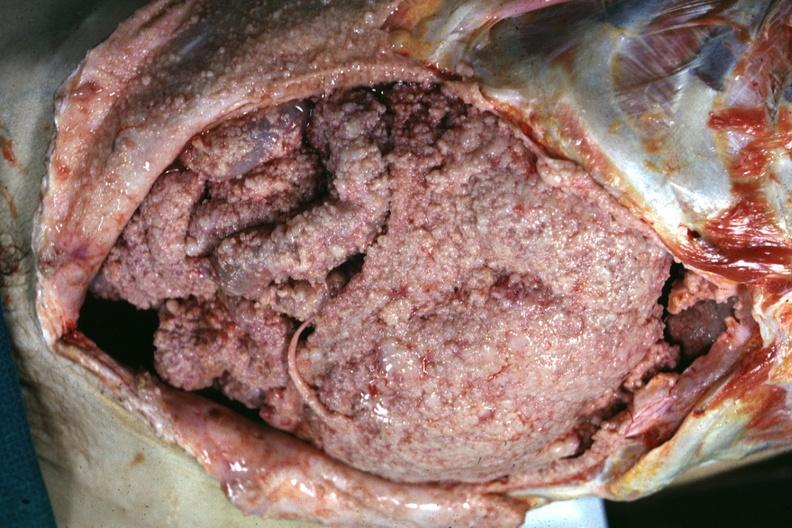what is present?
Answer the question using a single word or phrase. Mesothelioma 